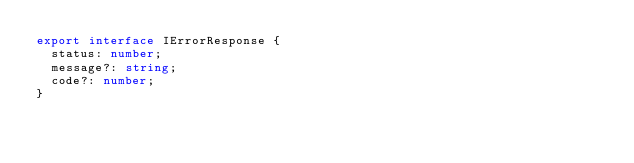<code> <loc_0><loc_0><loc_500><loc_500><_TypeScript_>export interface IErrorResponse {
  status: number;
  message?: string;
  code?: number;
}
</code> 